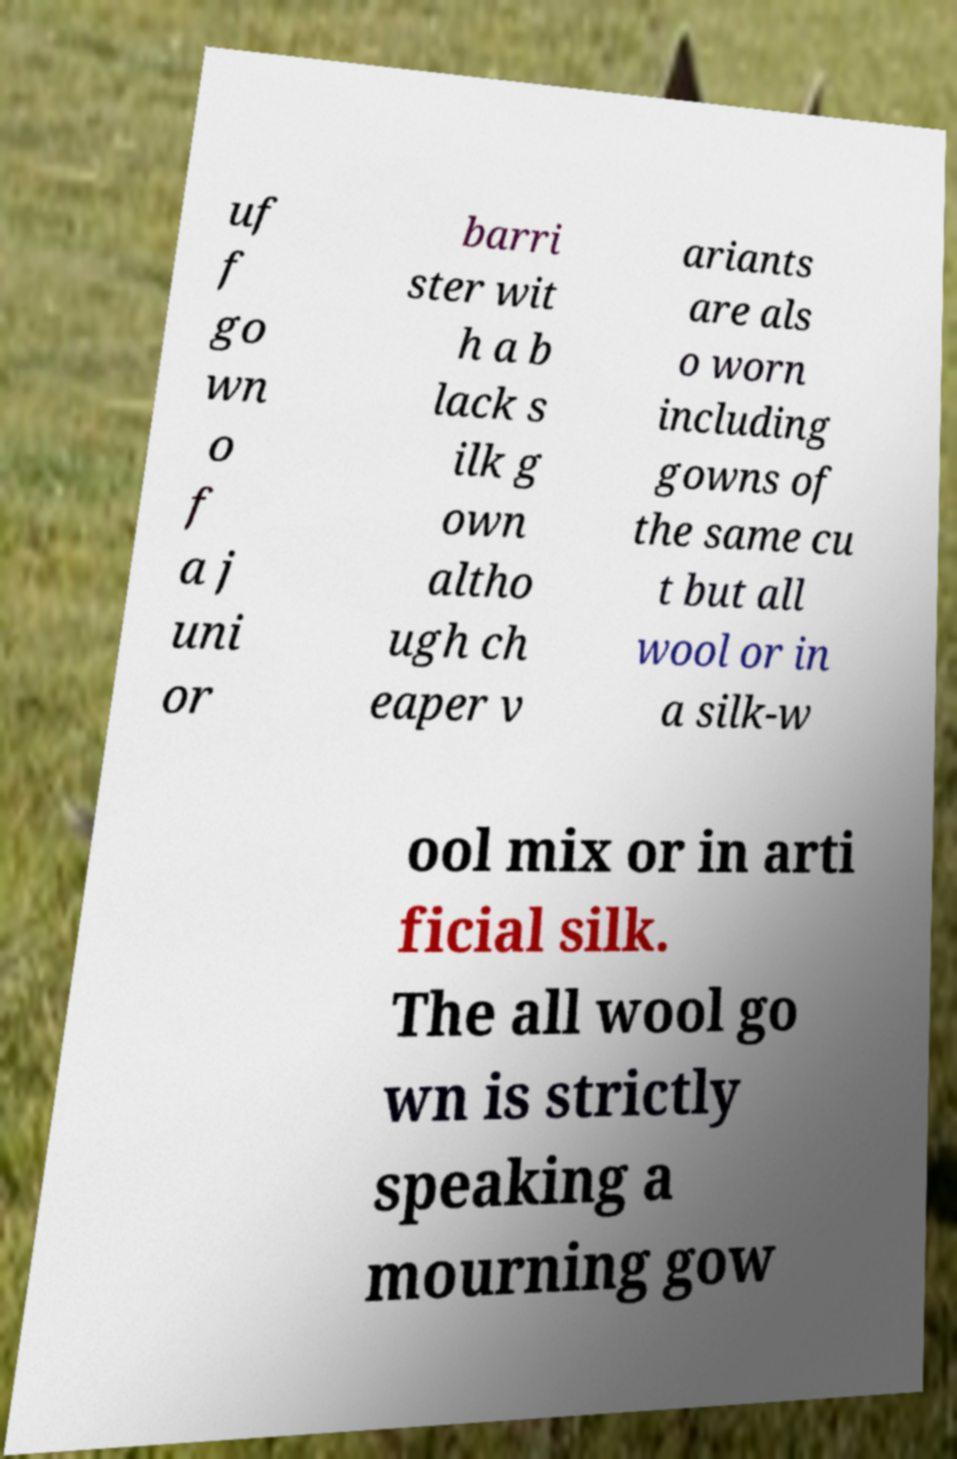Can you read and provide the text displayed in the image?This photo seems to have some interesting text. Can you extract and type it out for me? uf f go wn o f a j uni or barri ster wit h a b lack s ilk g own altho ugh ch eaper v ariants are als o worn including gowns of the same cu t but all wool or in a silk-w ool mix or in arti ficial silk. The all wool go wn is strictly speaking a mourning gow 